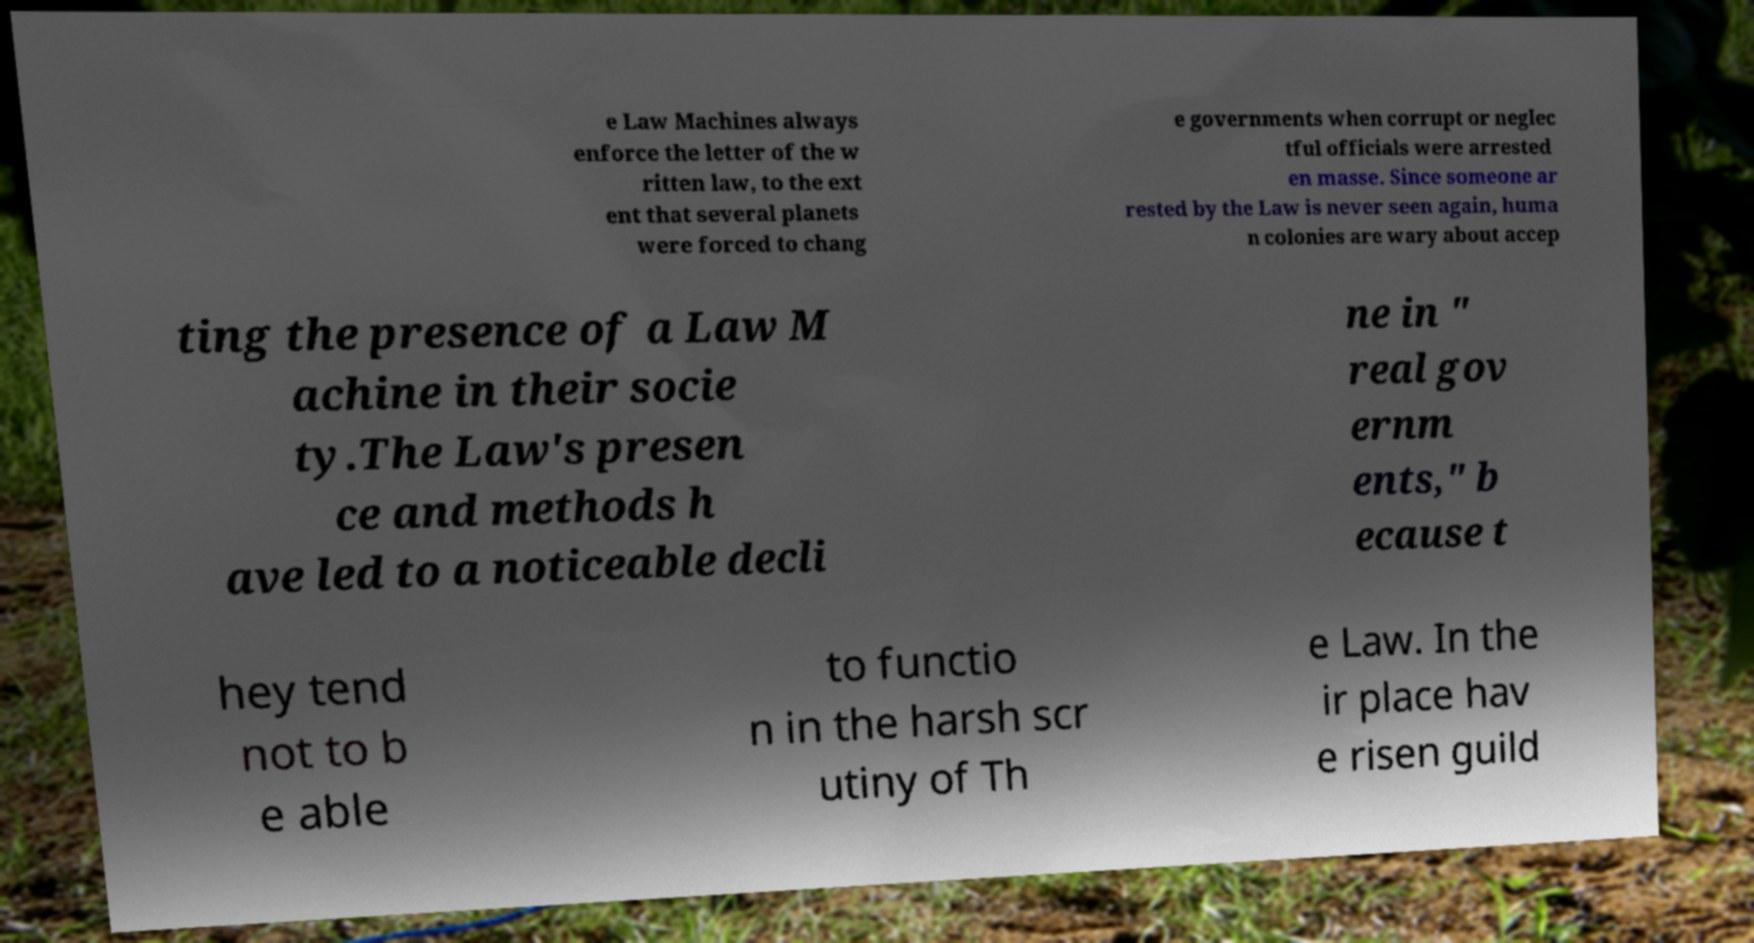Please identify and transcribe the text found in this image. e Law Machines always enforce the letter of the w ritten law, to the ext ent that several planets were forced to chang e governments when corrupt or neglec tful officials were arrested en masse. Since someone ar rested by the Law is never seen again, huma n colonies are wary about accep ting the presence of a Law M achine in their socie ty.The Law's presen ce and methods h ave led to a noticeable decli ne in " real gov ernm ents," b ecause t hey tend not to b e able to functio n in the harsh scr utiny of Th e Law. In the ir place hav e risen guild 